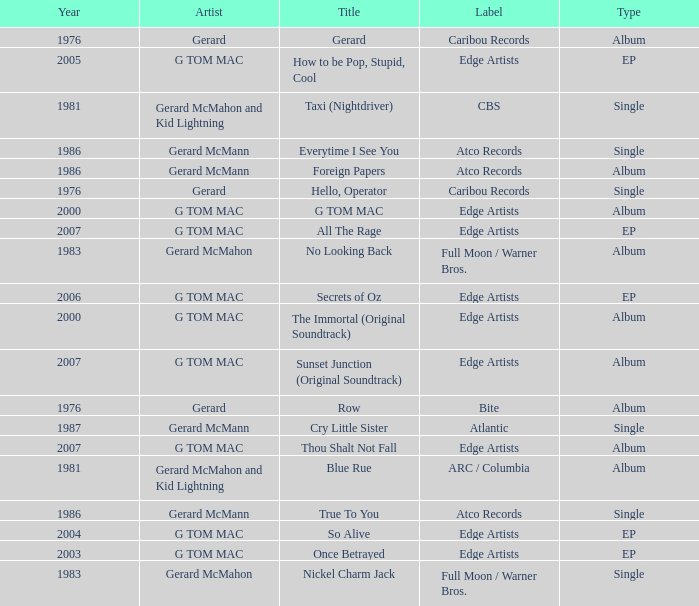Which Title has a Type of ep and a Year larger than 2003? So Alive, How to be Pop, Stupid, Cool, Secrets of Oz, All The Rage. Can you parse all the data within this table? {'header': ['Year', 'Artist', 'Title', 'Label', 'Type'], 'rows': [['1976', 'Gerard', 'Gerard', 'Caribou Records', 'Album'], ['2005', 'G TOM MAC', 'How to be Pop, Stupid, Cool', 'Edge Artists', 'EP'], ['1981', 'Gerard McMahon and Kid Lightning', 'Taxi (Nightdriver)', 'CBS', 'Single'], ['1986', 'Gerard McMann', 'Everytime I See You', 'Atco Records', 'Single'], ['1986', 'Gerard McMann', 'Foreign Papers', 'Atco Records', 'Album'], ['1976', 'Gerard', 'Hello, Operator', 'Caribou Records', 'Single'], ['2000', 'G TOM MAC', 'G TOM MAC', 'Edge Artists', 'Album'], ['2007', 'G TOM MAC', 'All The Rage', 'Edge Artists', 'EP'], ['1983', 'Gerard McMahon', 'No Looking Back', 'Full Moon / Warner Bros.', 'Album'], ['2006', 'G TOM MAC', 'Secrets of Oz', 'Edge Artists', 'EP'], ['2000', 'G TOM MAC', 'The Immortal (Original Soundtrack)', 'Edge Artists', 'Album'], ['2007', 'G TOM MAC', 'Sunset Junction (Original Soundtrack)', 'Edge Artists', 'Album'], ['1976', 'Gerard', 'Row', 'Bite', 'Album'], ['1987', 'Gerard McMann', 'Cry Little Sister', 'Atlantic', 'Single'], ['2007', 'G TOM MAC', 'Thou Shalt Not Fall', 'Edge Artists', 'Album'], ['1981', 'Gerard McMahon and Kid Lightning', 'Blue Rue', 'ARC / Columbia', 'Album'], ['1986', 'Gerard McMann', 'True To You', 'Atco Records', 'Single'], ['2004', 'G TOM MAC', 'So Alive', 'Edge Artists', 'EP'], ['2003', 'G TOM MAC', 'Once Betrayed', 'Edge Artists', 'EP'], ['1983', 'Gerard McMahon', 'Nickel Charm Jack', 'Full Moon / Warner Bros.', 'Single']]} 